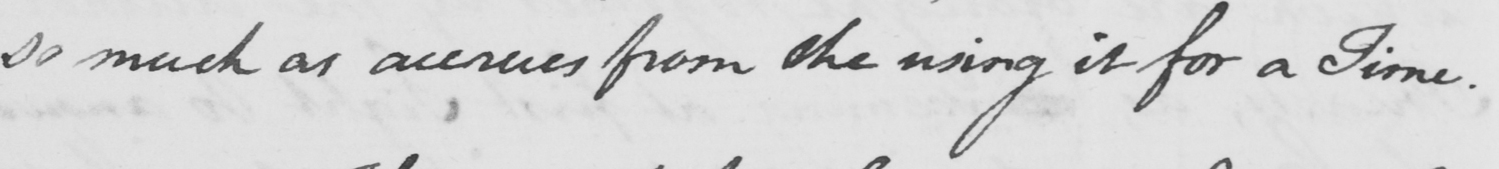What is written in this line of handwriting? so much as accrues from the using it for a Time . 